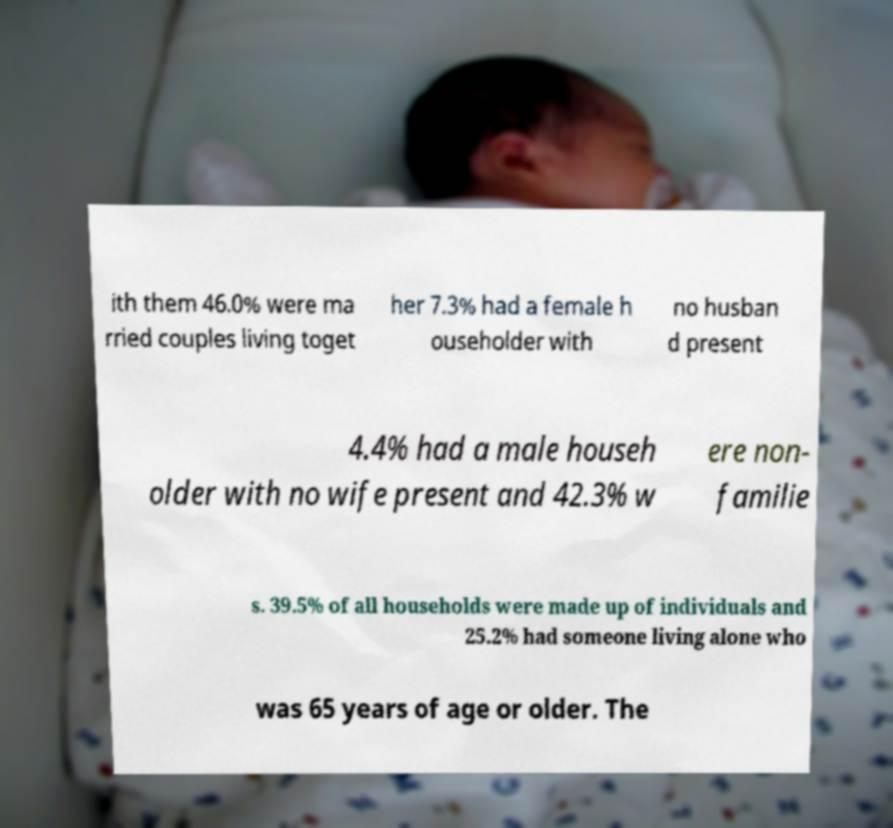Please read and relay the text visible in this image. What does it say? ith them 46.0% were ma rried couples living toget her 7.3% had a female h ouseholder with no husban d present 4.4% had a male househ older with no wife present and 42.3% w ere non- familie s. 39.5% of all households were made up of individuals and 25.2% had someone living alone who was 65 years of age or older. The 